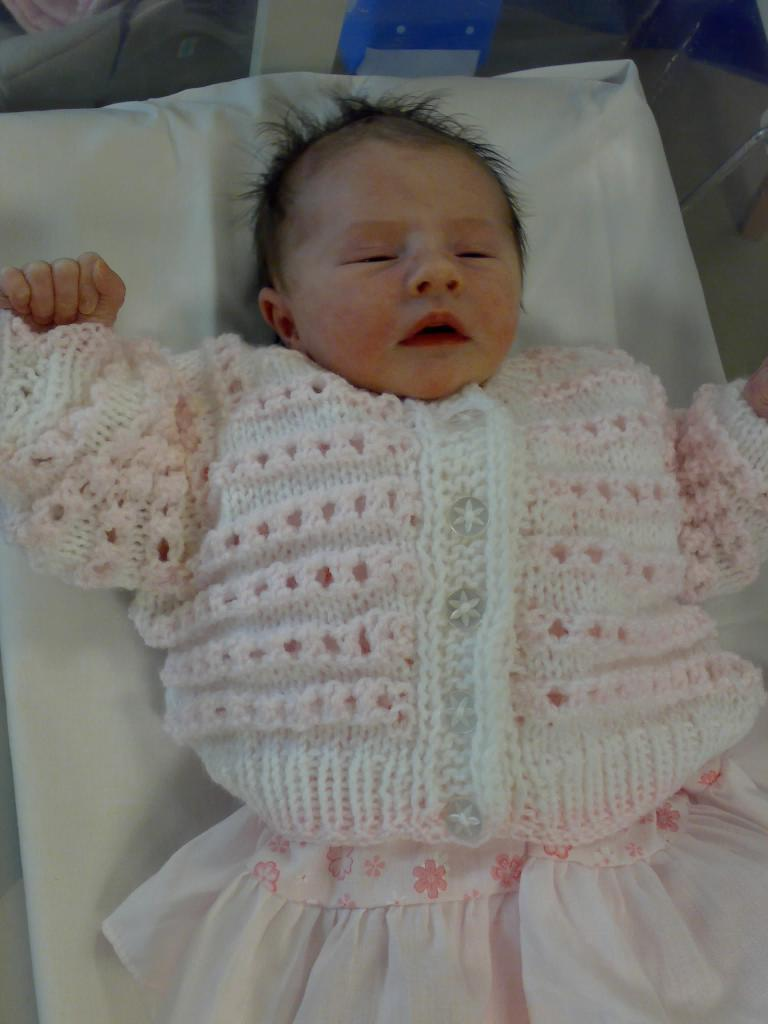What is the main subject of the picture? The main subject of the picture is a baby. What is the baby wearing in the image? The baby is wearing a dress. What type of cream is being applied to the baby's skin in the image? There is no cream visible in the image, and the baby's skin is not being treated or applied with any substance. What is the baby's opinion on the use of zinc in the image? The baby's opinion cannot be determined from the image, as babies are not capable of expressing opinions on such topics. 